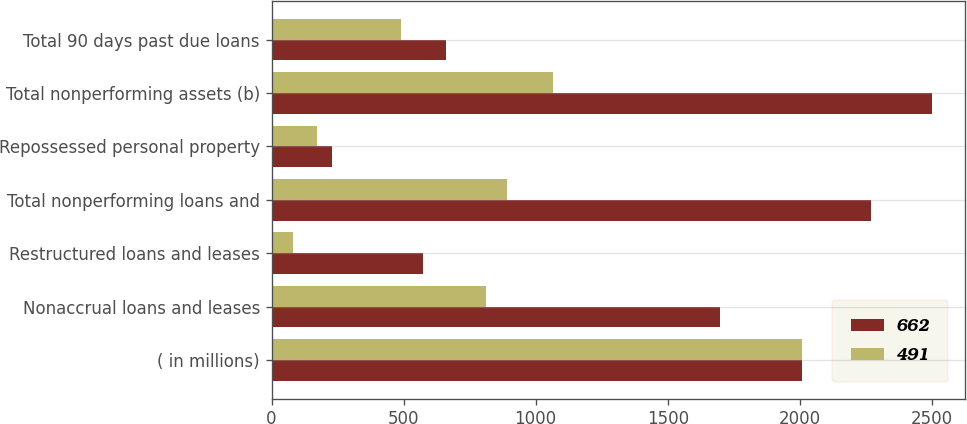Convert chart to OTSL. <chart><loc_0><loc_0><loc_500><loc_500><stacked_bar_chart><ecel><fcel>( in millions)<fcel>Nonaccrual loans and leases<fcel>Restructured loans and leases<fcel>Total nonperforming loans and<fcel>Repossessed personal property<fcel>Total nonperforming assets (b)<fcel>Total 90 days past due loans<nl><fcel>662<fcel>2008<fcel>1696<fcel>574<fcel>2270<fcel>230<fcel>2500<fcel>662<nl><fcel>491<fcel>2007<fcel>813<fcel>80<fcel>893<fcel>171<fcel>1064<fcel>491<nl></chart> 